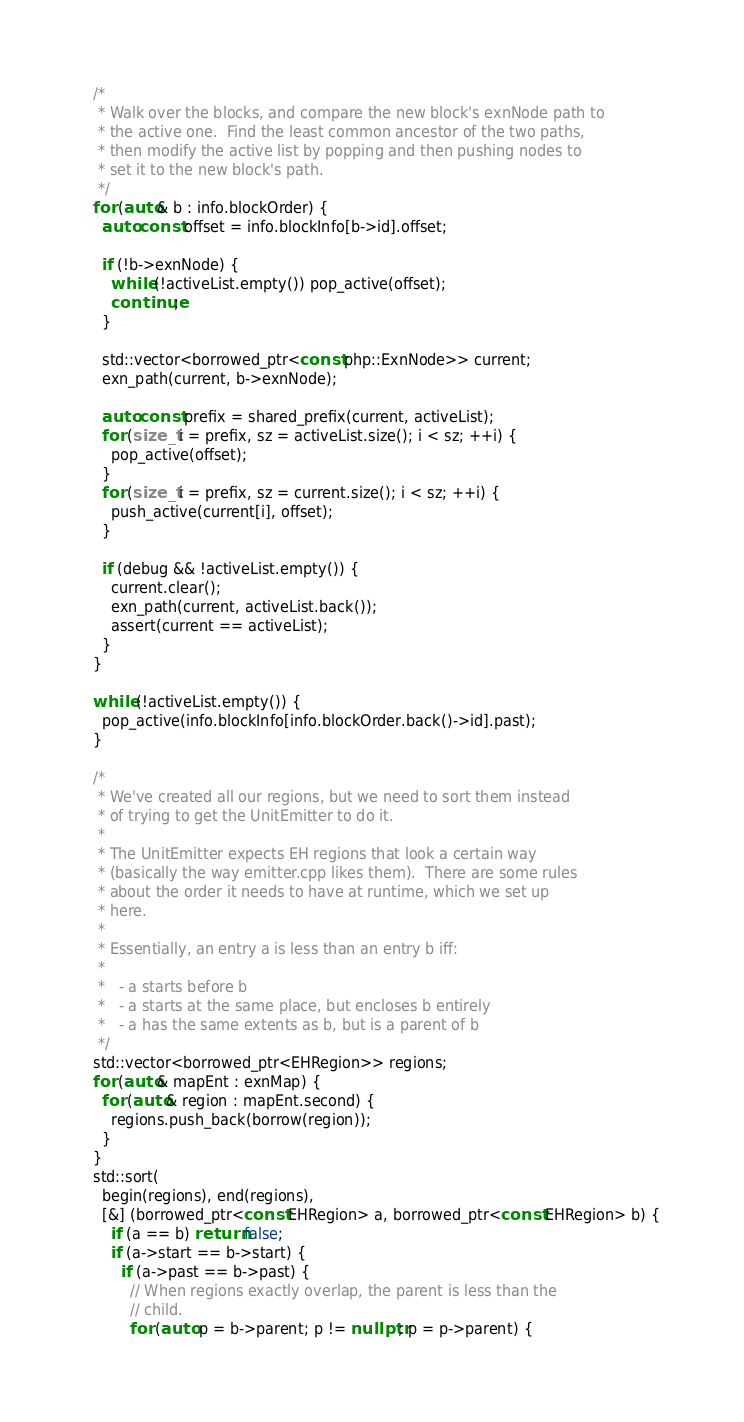<code> <loc_0><loc_0><loc_500><loc_500><_C++_>
  /*
   * Walk over the blocks, and compare the new block's exnNode path to
   * the active one.  Find the least common ancestor of the two paths,
   * then modify the active list by popping and then pushing nodes to
   * set it to the new block's path.
   */
  for (auto& b : info.blockOrder) {
    auto const offset = info.blockInfo[b->id].offset;

    if (!b->exnNode) {
      while (!activeList.empty()) pop_active(offset);
      continue;
    }

    std::vector<borrowed_ptr<const php::ExnNode>> current;
    exn_path(current, b->exnNode);

    auto const prefix = shared_prefix(current, activeList);
    for (size_t i = prefix, sz = activeList.size(); i < sz; ++i) {
      pop_active(offset);
    }
    for (size_t i = prefix, sz = current.size(); i < sz; ++i) {
      push_active(current[i], offset);
    }

    if (debug && !activeList.empty()) {
      current.clear();
      exn_path(current, activeList.back());
      assert(current == activeList);
    }
  }

  while (!activeList.empty()) {
    pop_active(info.blockInfo[info.blockOrder.back()->id].past);
  }

  /*
   * We've created all our regions, but we need to sort them instead
   * of trying to get the UnitEmitter to do it.
   *
   * The UnitEmitter expects EH regions that look a certain way
   * (basically the way emitter.cpp likes them).  There are some rules
   * about the order it needs to have at runtime, which we set up
   * here.
   *
   * Essentially, an entry a is less than an entry b iff:
   *
   *   - a starts before b
   *   - a starts at the same place, but encloses b entirely
   *   - a has the same extents as b, but is a parent of b
   */
  std::vector<borrowed_ptr<EHRegion>> regions;
  for (auto& mapEnt : exnMap) {
    for (auto& region : mapEnt.second) {
      regions.push_back(borrow(region));
    }
  }
  std::sort(
    begin(regions), end(regions),
    [&] (borrowed_ptr<const EHRegion> a, borrowed_ptr<const EHRegion> b) {
      if (a == b) return false;
      if (a->start == b->start) {
        if (a->past == b->past) {
          // When regions exactly overlap, the parent is less than the
          // child.
          for (auto p = b->parent; p != nullptr; p = p->parent) {</code> 